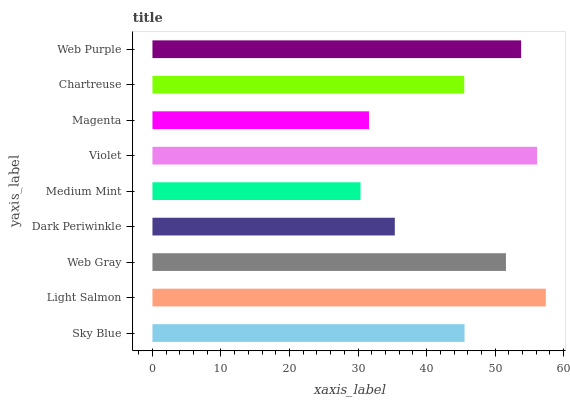Is Medium Mint the minimum?
Answer yes or no. Yes. Is Light Salmon the maximum?
Answer yes or no. Yes. Is Web Gray the minimum?
Answer yes or no. No. Is Web Gray the maximum?
Answer yes or no. No. Is Light Salmon greater than Web Gray?
Answer yes or no. Yes. Is Web Gray less than Light Salmon?
Answer yes or no. Yes. Is Web Gray greater than Light Salmon?
Answer yes or no. No. Is Light Salmon less than Web Gray?
Answer yes or no. No. Is Sky Blue the high median?
Answer yes or no. Yes. Is Sky Blue the low median?
Answer yes or no. Yes. Is Web Gray the high median?
Answer yes or no. No. Is Chartreuse the low median?
Answer yes or no. No. 